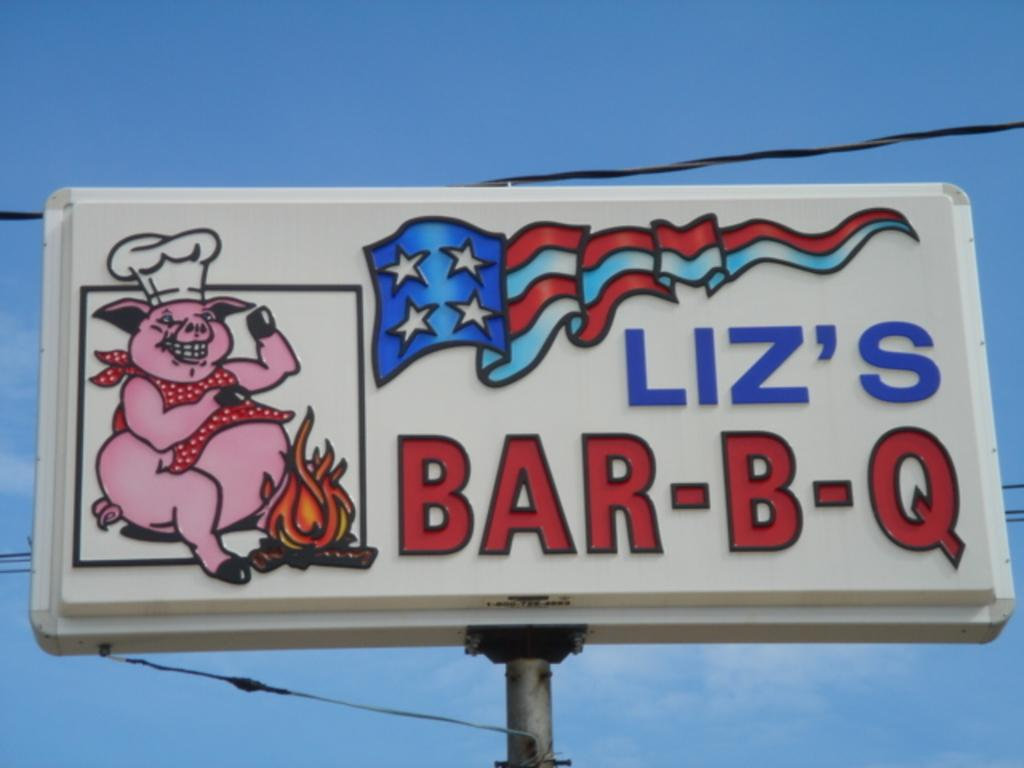<image>
Write a terse but informative summary of the picture. A billboard sign that shows a pig sitting at a campfire with a chef hat and reads Liz's Bar-B-Q 